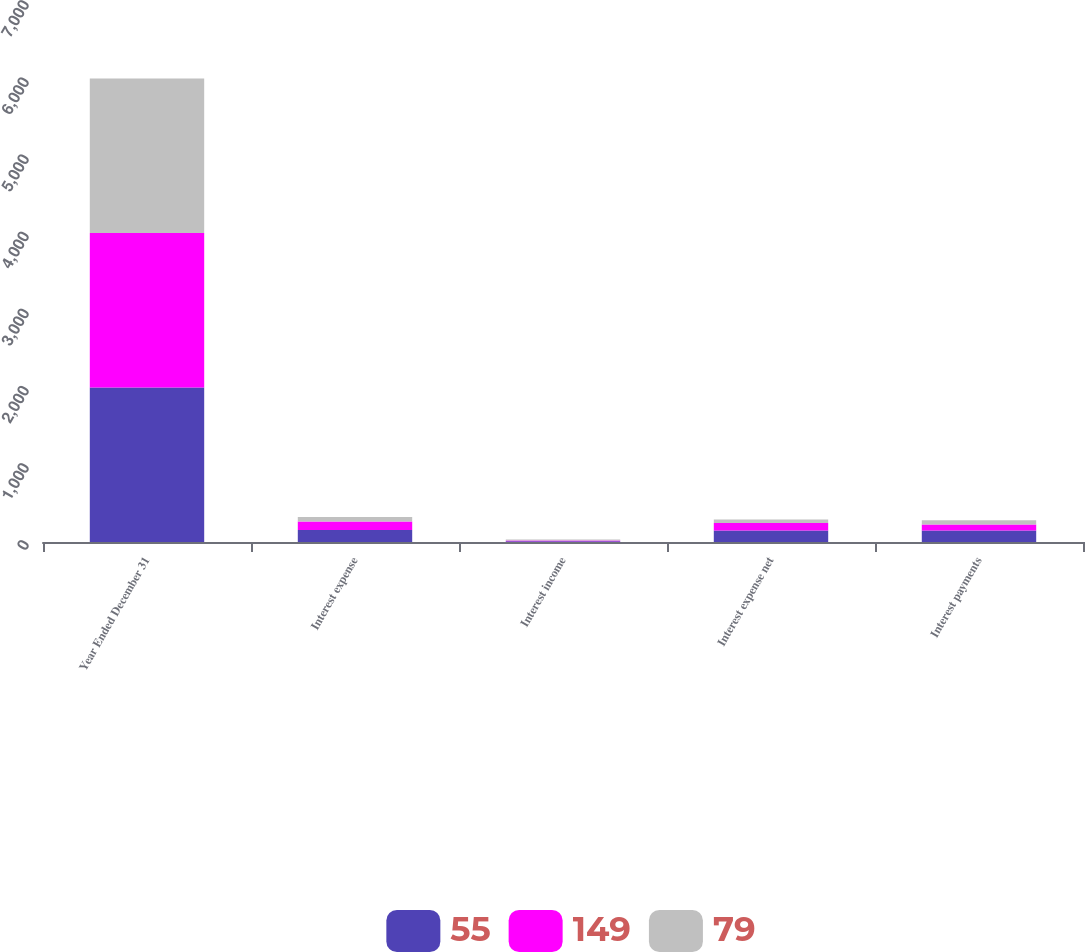Convert chart. <chart><loc_0><loc_0><loc_500><loc_500><stacked_bar_chart><ecel><fcel>Year Ended December 31<fcel>Interest expense<fcel>Interest income<fcel>Interest expense net<fcel>Interest payments<nl><fcel>55<fcel>2004<fcel>157<fcel>9<fcel>148<fcel>149<nl><fcel>149<fcel>2003<fcel>108<fcel>10<fcel>98<fcel>79<nl><fcel>79<fcel>2002<fcel>58<fcel>13<fcel>45<fcel>55<nl></chart> 